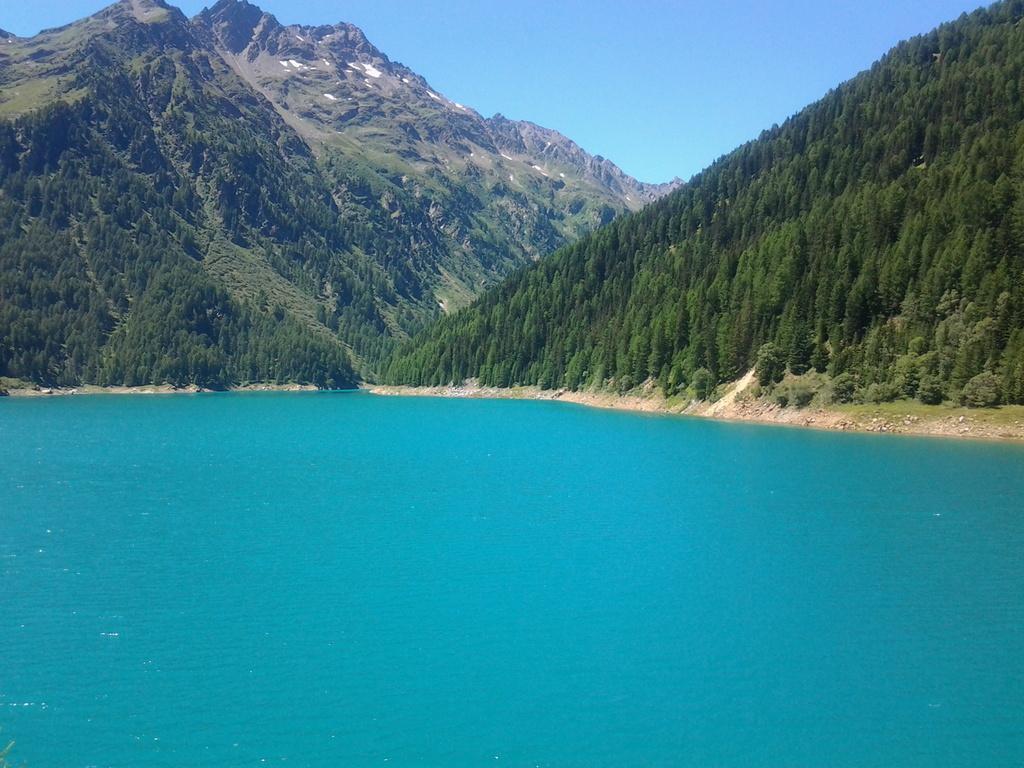Can you describe this image briefly? In this picture we can see a blue sea, surrounded by green trees and mountains. The sky is blue. 